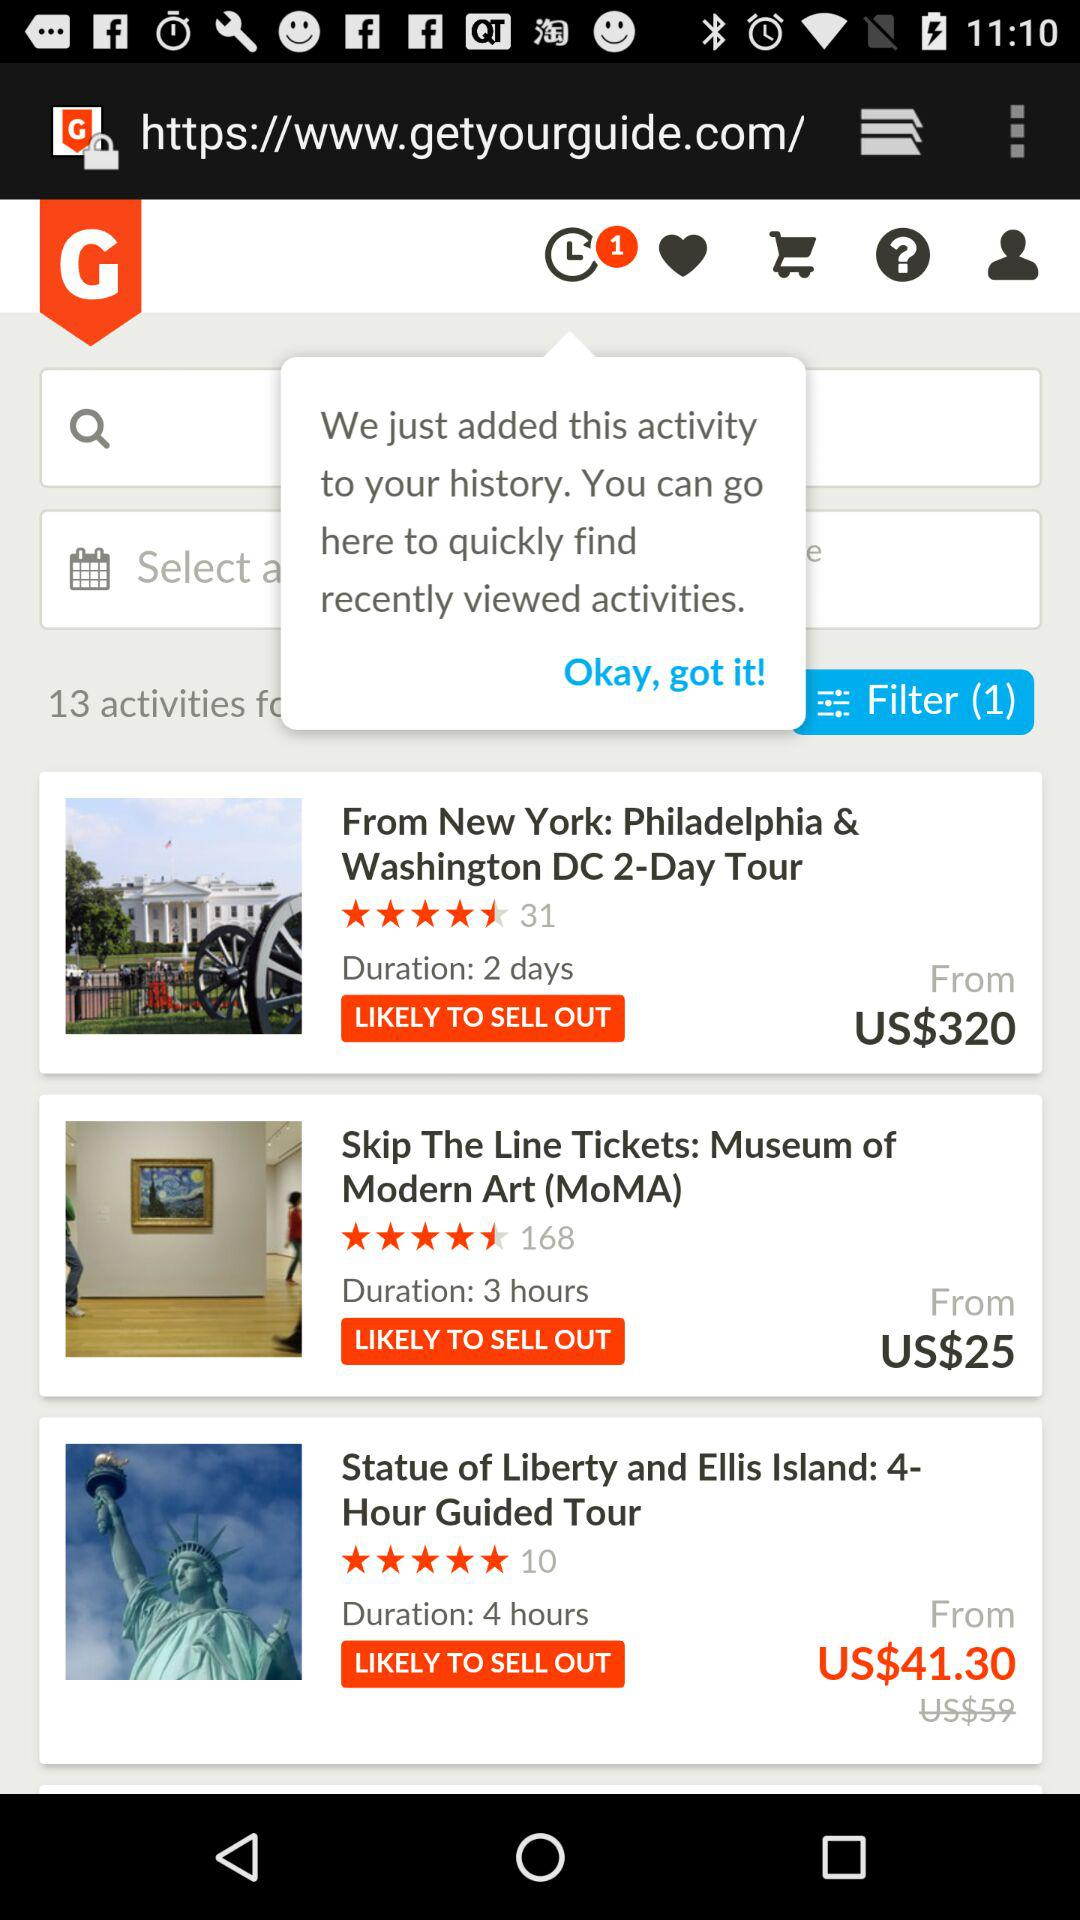What was the original price of "Statue of Liberty and Ellis Island"? The original price of "Statue of Liberty and Ellis Island" is US$59. 